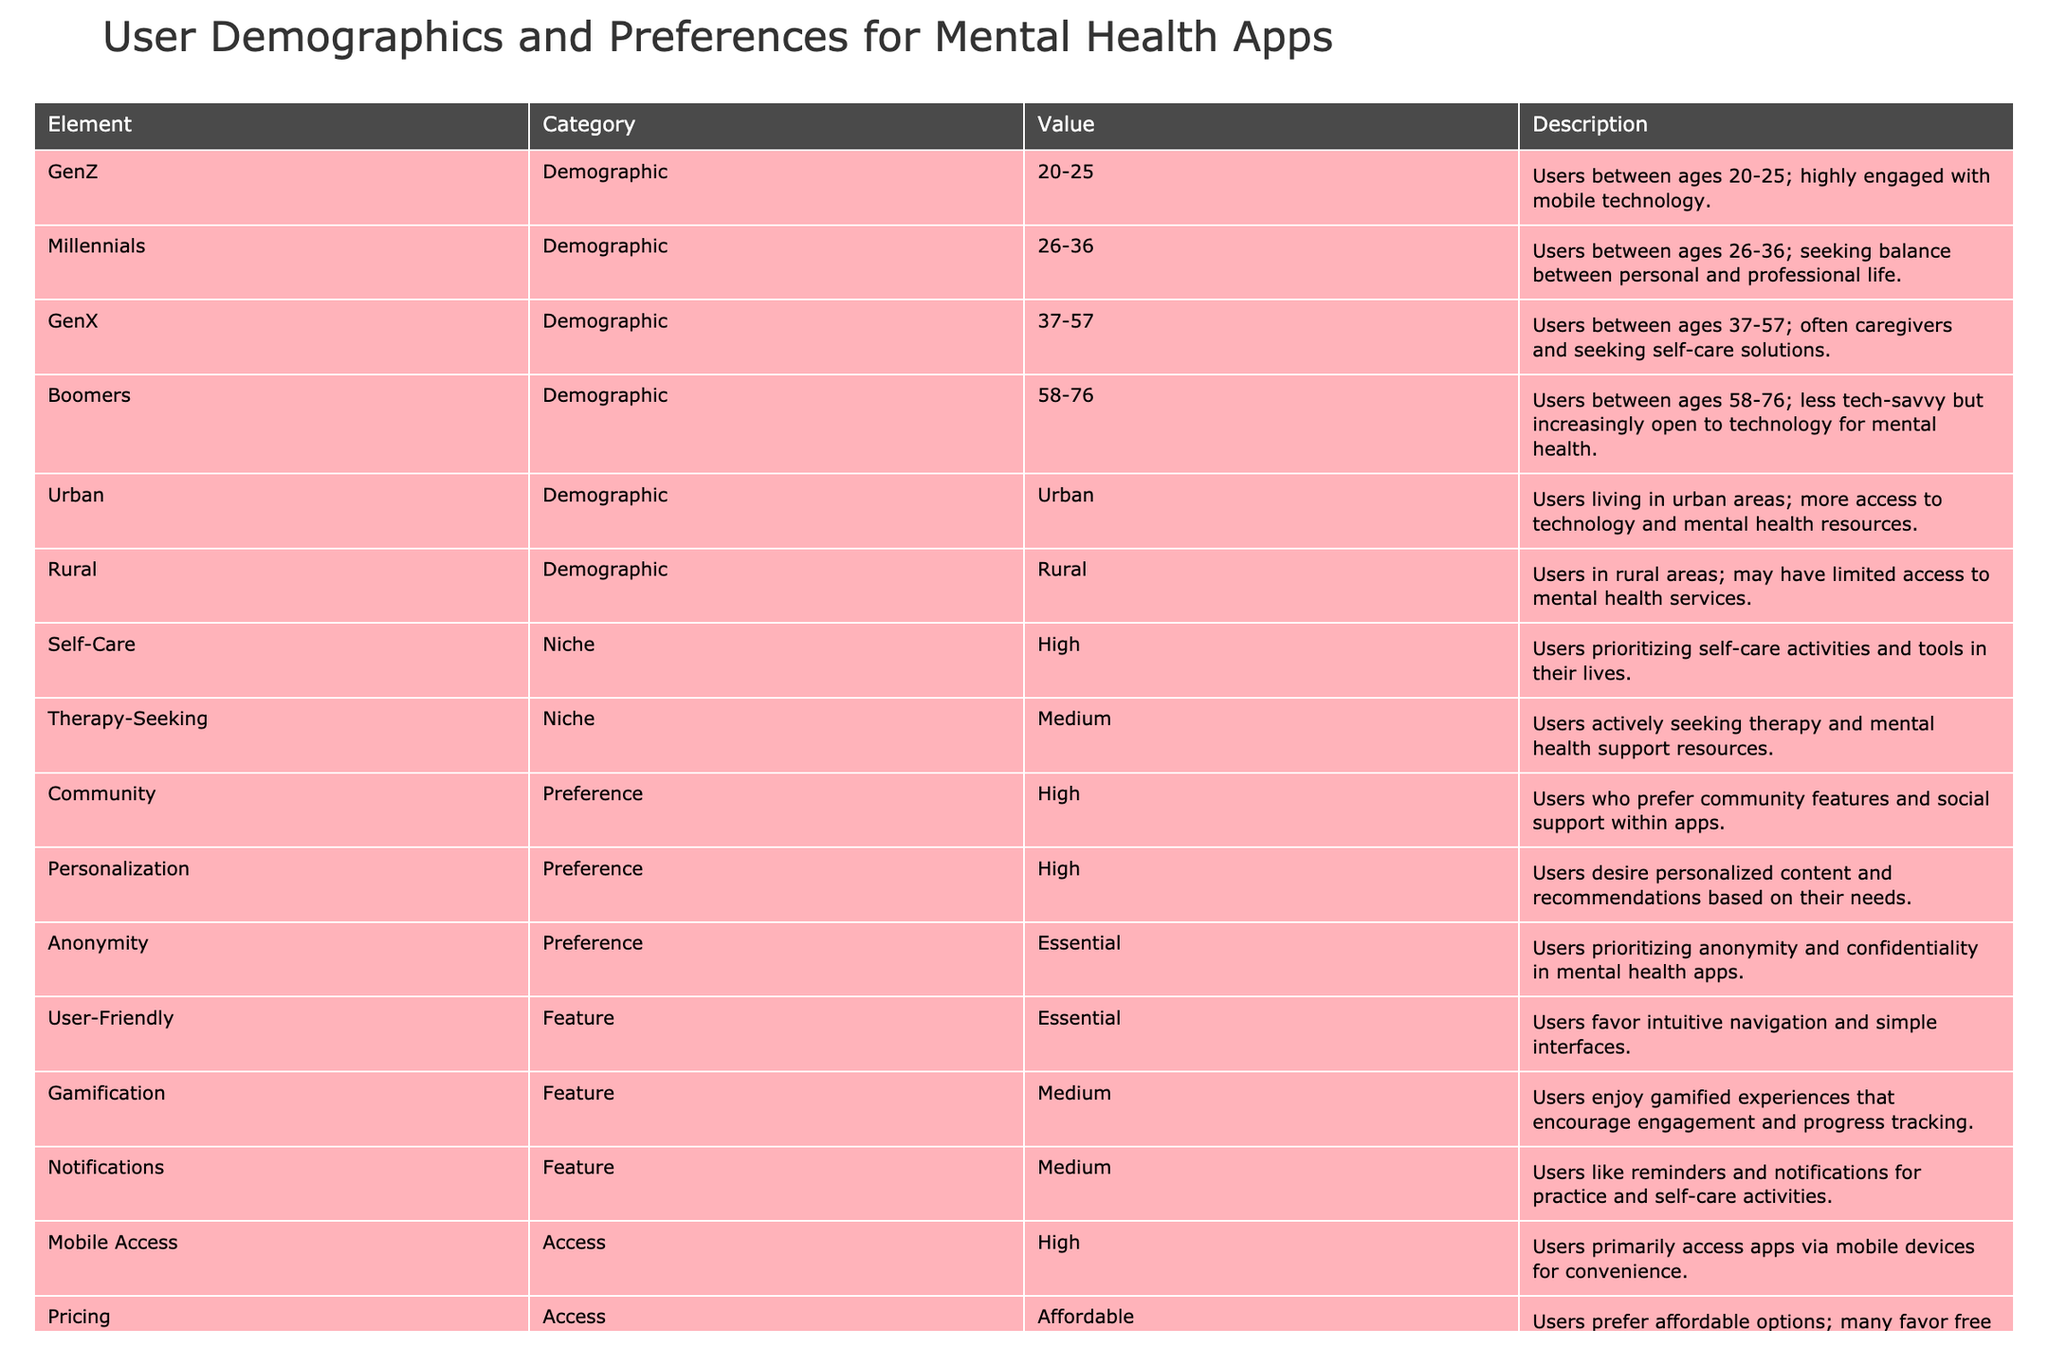What age group does Gen Z represent in the table? Gen Z is defined in the table as users between the ages of 20-25. This information can be retrieved directly from the table under the "Element" column for Gen Z.
Answer: 20-25 What is the primary preference for users regarding anonymity in mental health apps? The table indicates that anonymity is considered essential for users, as they prioritize confidentiality in mental health apps. This is found under the "Element" for Anonymity.
Answer: Essential How many demographic groups are identified in the table? The table lists four demographic groups: Gen Z, Millennials, Gen X, and Boomers. To find the total, we simply count these unique entries under the "Element" column that fall in the "Demographic" category.
Answer: Four Which demographic group values self-care the most? Self-Care is categorized as a niche group with a high priority among users. However, it does not belong to any specific demographic group. Instead, this preference can be associated with various age groups but is reported collectively.
Answer: N/A Does the table indicate that users in rural areas have high access to mental health resources? The table shows that rural users may have limited access to mental health services, explicitly mentioning their demographic as a category, thus suggesting that access is not high based on the information provided.
Answer: No What is the average importance level of features such as gamification and notifications? The importance level for both gamification and notifications is listed as medium. To find the average importance level across these features, we would assign numerical values (e.g., 1 for medium, 0 for low) and calculate the average. Since both are medium, the average is medium too.
Answer: Medium Which group of users actively seeks therapy? The table classifies Therapy-Seeking as a niche category with a medium importance level. Therefore, while it indicates interest in therapy, it does not specify a demographic group but relates to users who actively look for therapy resources.
Answer: N/A What feature do users consider essential for mental health apps? According to the table, users consider "User-Friendly" features essential, prioritizing intuitive navigation and simple interfaces. This information can be found under the "Feature" category associated with description and corresponding values.
Answer: Essential How does the value of personalized content compare to community features? Both Personalized Content and Community are classified as high preferences by users. While both are similarly valued, personalized content does not have a numerical identifier in this specific case, but they are both equally preferred.
Answer: High 